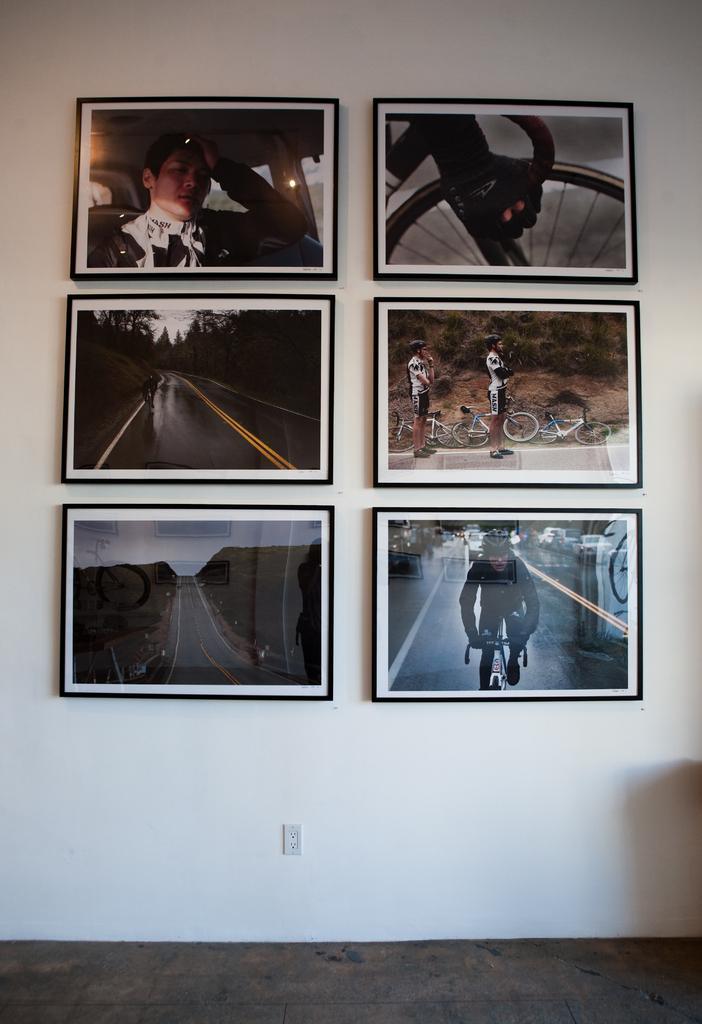Can you describe this image briefly? In the center of the image we can see photo frames are there. In the background of the image wall is there. At the bottom of the image floor is there. In the middle of the image socket is there. 